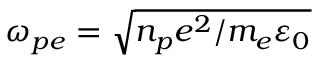<formula> <loc_0><loc_0><loc_500><loc_500>\omega _ { p e } = \sqrt { n _ { p } e ^ { 2 } / m _ { e } \varepsilon _ { 0 } }</formula> 